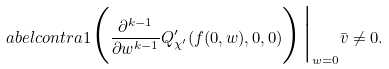Convert formula to latex. <formula><loc_0><loc_0><loc_500><loc_500>\L a b e l { c o n t r a 1 } \Big ( \frac { \partial ^ { k - 1 } } { \partial w ^ { k - 1 } } Q ^ { \prime } _ { \chi ^ { \prime } } ( f ( 0 , w ) , 0 , 0 ) \Big ) \Big | _ { w = 0 } \bar { v } \neq 0 .</formula> 